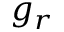<formula> <loc_0><loc_0><loc_500><loc_500>g _ { r }</formula> 